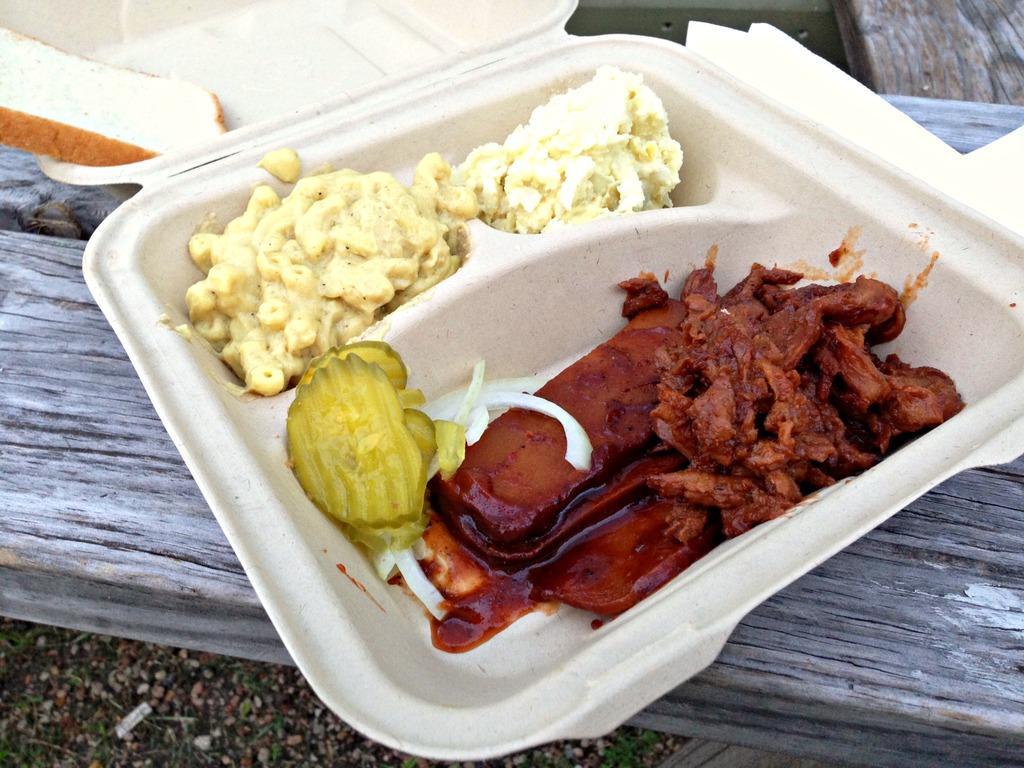Please provide a concise description of this image. In this image, we can see food items in the box, which is placed on the wooden surface. At the bottom, there is ground. 